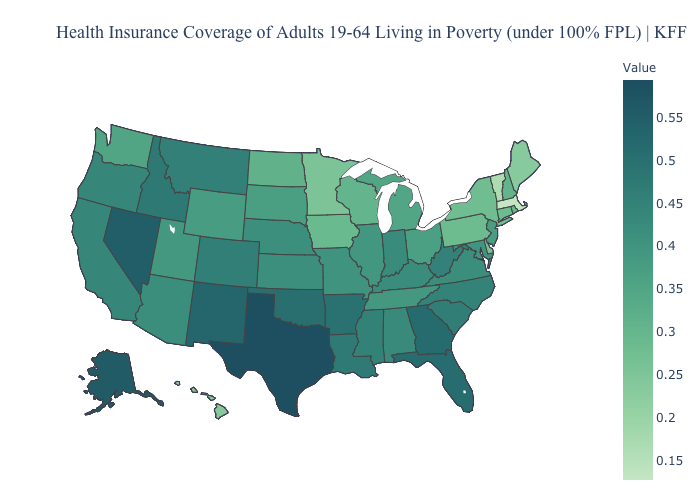Which states have the lowest value in the Northeast?
Be succinct. Massachusetts. Does the map have missing data?
Quick response, please. No. Does Missouri have the highest value in the MidWest?
Answer briefly. No. Which states have the highest value in the USA?
Give a very brief answer. Texas. Does Iowa have the highest value in the MidWest?
Give a very brief answer. No. 